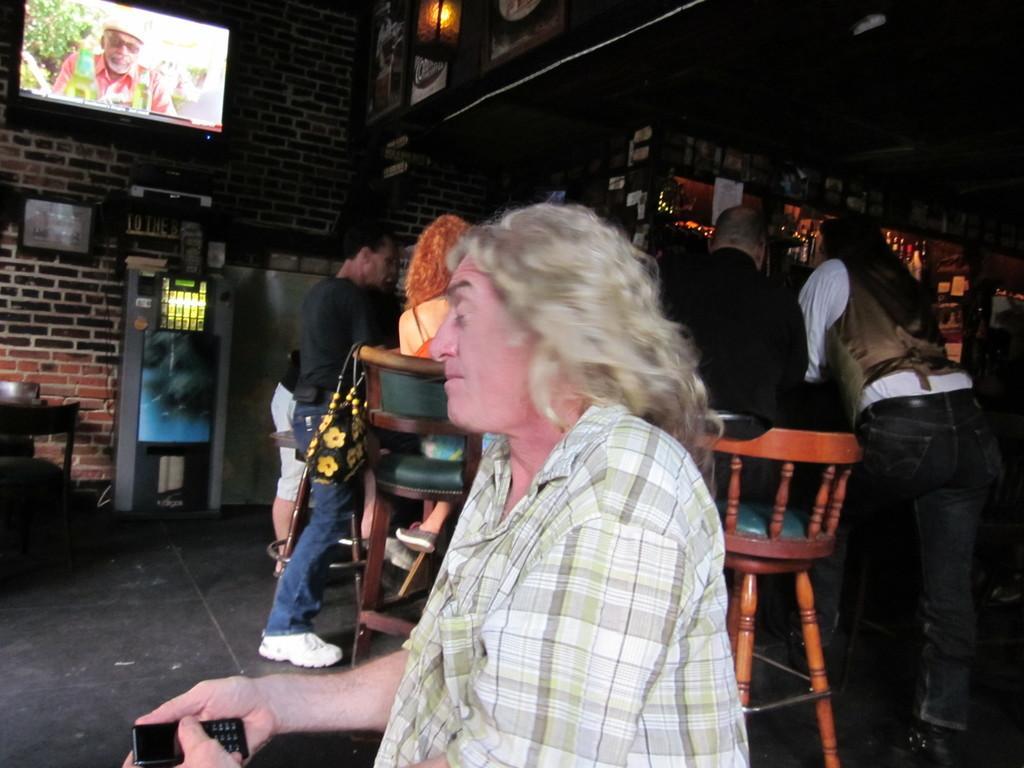Could you give a brief overview of what you see in this image? A woman at the center of the image sitting closing her eyes. She has a fair skin. She holds mobile in her hand. She wears a shirt. She has a white hair. The location is like a bar. There are few people behind her at the bar counter. The bar is very dull,dark walls. There is a TV at a wall. 